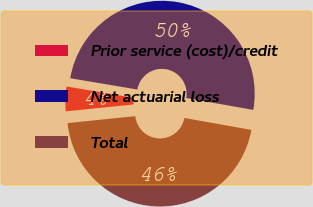<chart> <loc_0><loc_0><loc_500><loc_500><pie_chart><fcel>Prior service (cost)/credit<fcel>Net actuarial loss<fcel>Total<nl><fcel>4.28%<fcel>50.14%<fcel>45.58%<nl></chart> 